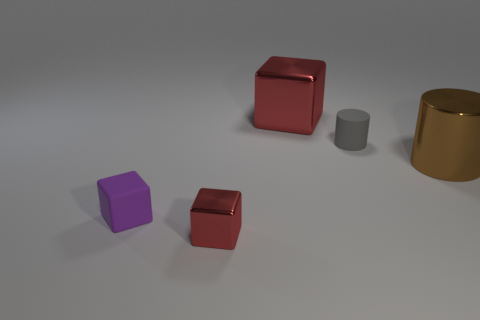Subtract all metal blocks. How many blocks are left? 1 Subtract all purple cubes. How many cubes are left? 2 Subtract 1 blocks. How many blocks are left? 2 Add 4 large gray metallic blocks. How many objects exist? 9 Subtract all cylinders. How many objects are left? 3 Subtract all purple cylinders. How many purple blocks are left? 1 Subtract all tiny purple blocks. Subtract all gray spheres. How many objects are left? 4 Add 3 rubber cylinders. How many rubber cylinders are left? 4 Add 4 tiny purple objects. How many tiny purple objects exist? 5 Subtract 0 brown blocks. How many objects are left? 5 